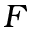<formula> <loc_0><loc_0><loc_500><loc_500>F</formula> 